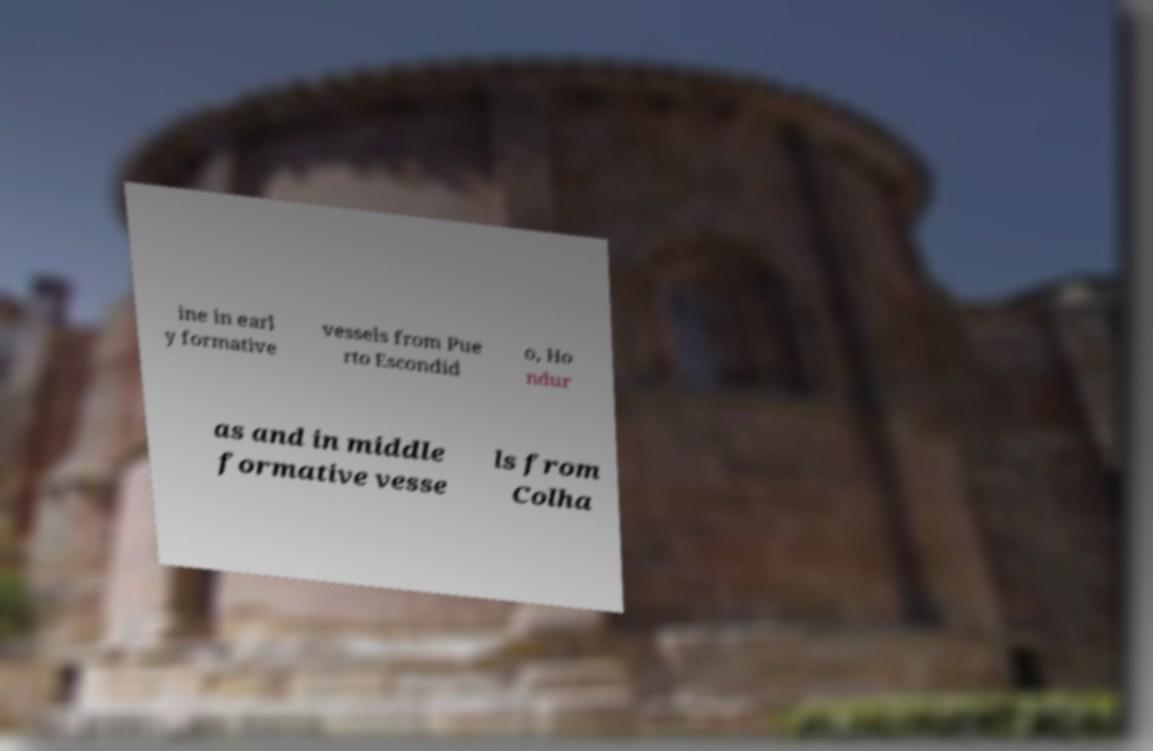For documentation purposes, I need the text within this image transcribed. Could you provide that? ine in earl y formative vessels from Pue rto Escondid o, Ho ndur as and in middle formative vesse ls from Colha 